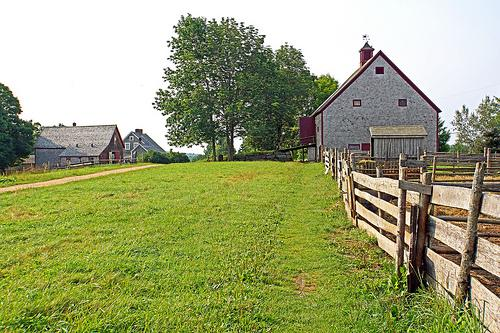Question: what kind of neighborhood is this?
Choices:
A. Cul de sac.
B. Farm.
C. It is a neighborhood in the country.
D. Suburbs.
Answer with the letter. Answer: C Question: who is the owner of this property?
Choices:
A. The man.
B. A rancher.
C. The woman.
D. The realtor.
Answer with the letter. Answer: B Question: why is there a wooden fence around the property?
Choices:
A. To protect children.
B. To secure pets.
C. To mark property.
D. To keep animals from escaping.
Answer with the letter. Answer: D Question: how many houses are there in this property?
Choices:
A. Three.
B. Four.
C. Six.
D. Seven.
Answer with the letter. Answer: A 